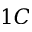<formula> <loc_0><loc_0><loc_500><loc_500>1 C</formula> 